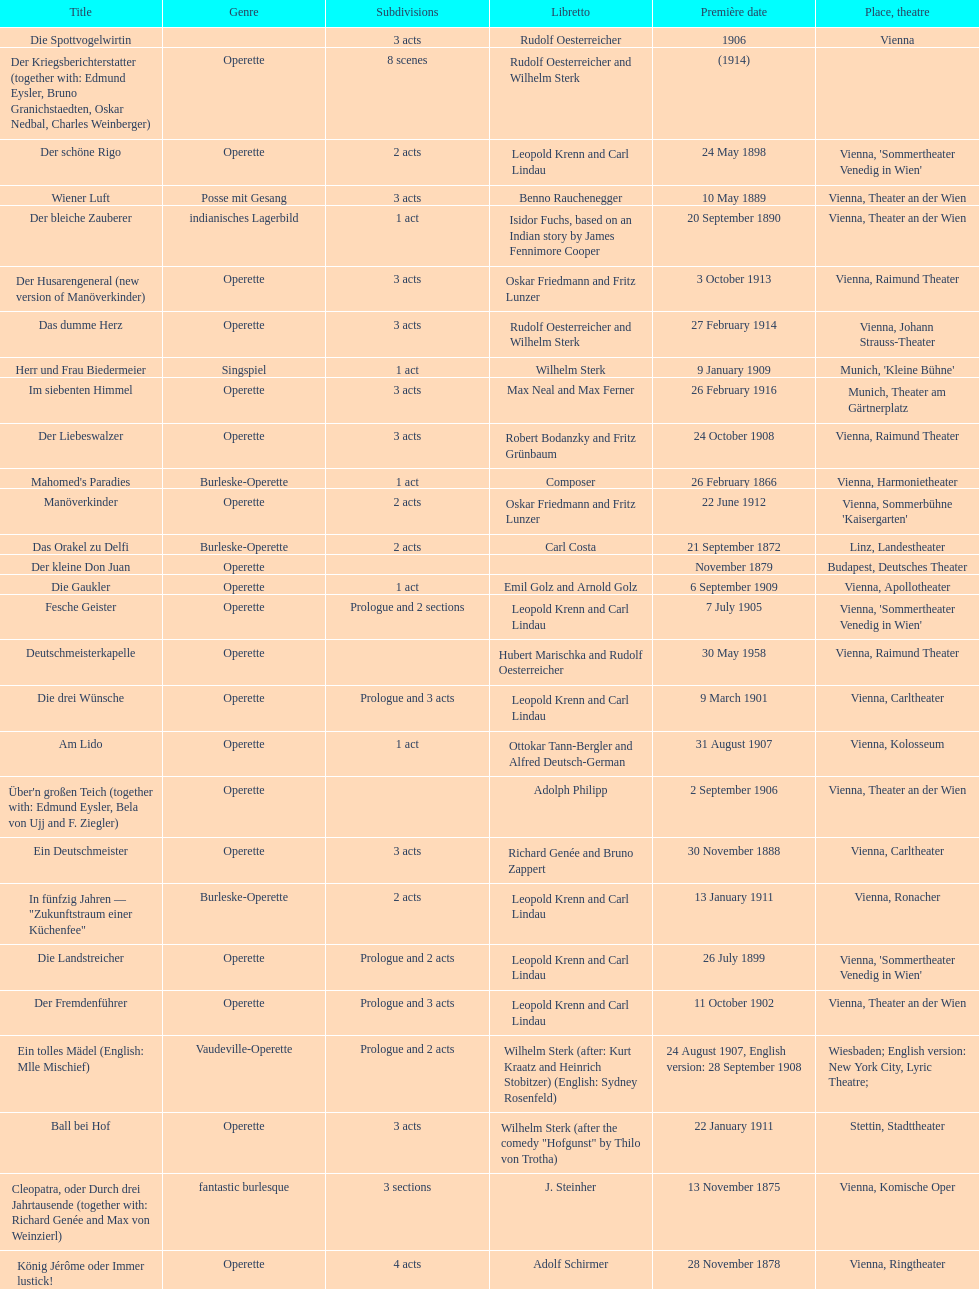Which year did he release his last operetta? 1930. 